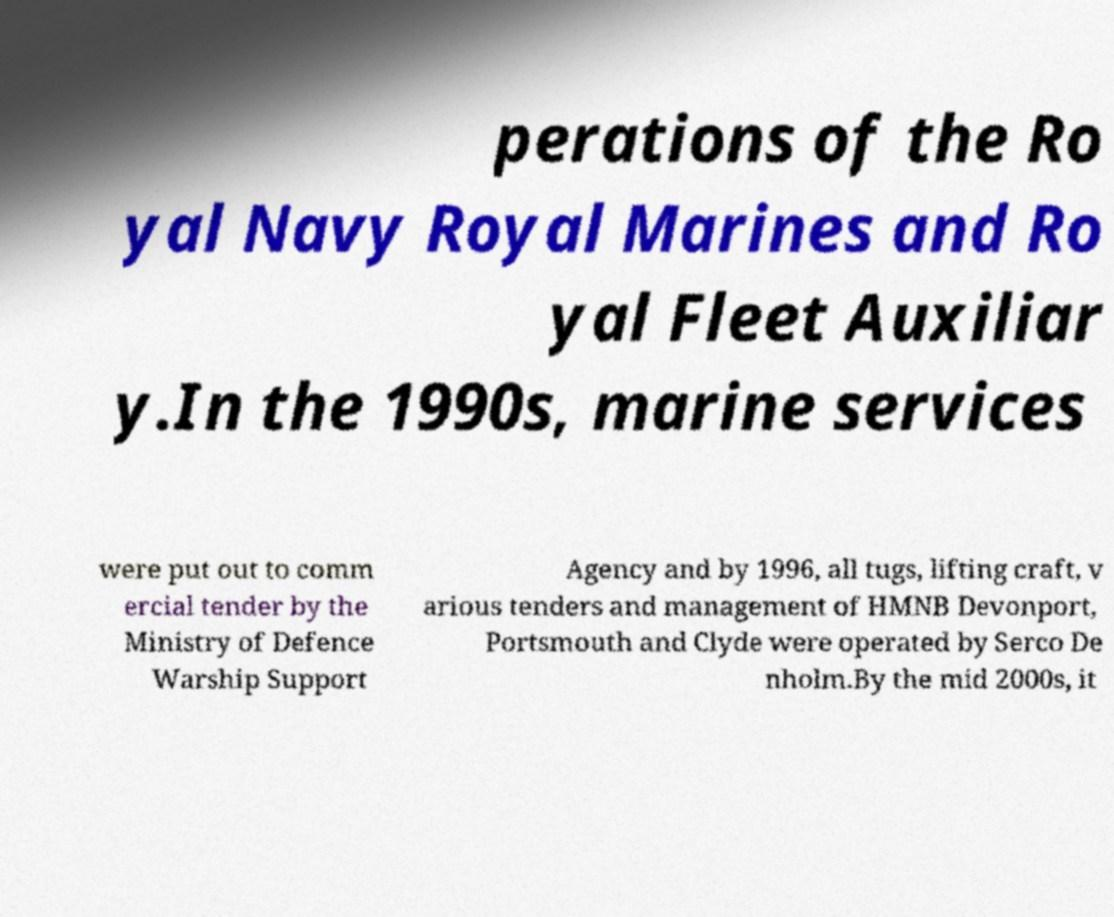Please identify and transcribe the text found in this image. perations of the Ro yal Navy Royal Marines and Ro yal Fleet Auxiliar y.In the 1990s, marine services were put out to comm ercial tender by the Ministry of Defence Warship Support Agency and by 1996, all tugs, lifting craft, v arious tenders and management of HMNB Devonport, Portsmouth and Clyde were operated by Serco De nholm.By the mid 2000s, it 